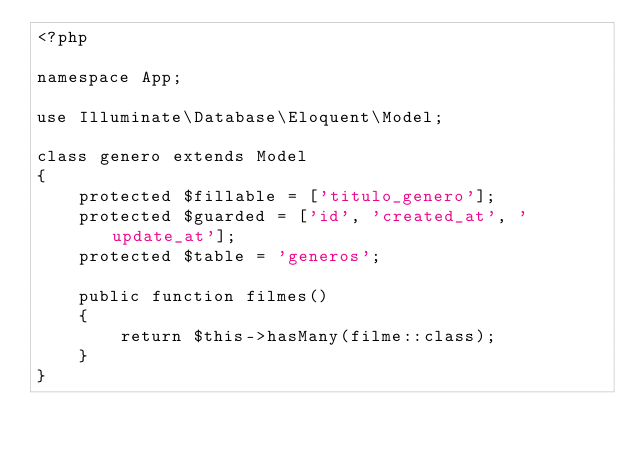<code> <loc_0><loc_0><loc_500><loc_500><_PHP_><?php

namespace App;

use Illuminate\Database\Eloquent\Model;

class genero extends Model
{
    protected $fillable = ['titulo_genero'];
    protected $guarded = ['id', 'created_at', 'update_at'];
    protected $table = 'generos';

    public function filmes()
    {
        return $this->hasMany(filme::class);
    }
}
</code> 